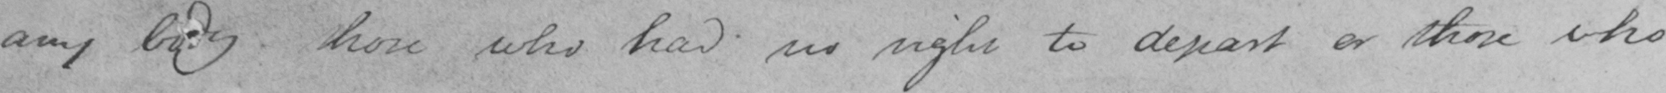Can you read and transcribe this handwriting? any body those who had no right to depart or those who 